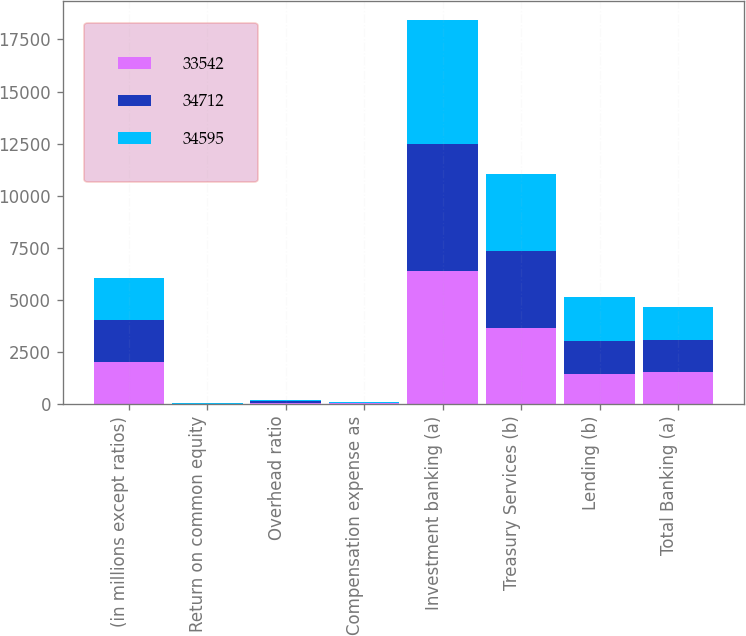Convert chart. <chart><loc_0><loc_0><loc_500><loc_500><stacked_bar_chart><ecel><fcel>(in millions except ratios)<fcel>Return on common equity<fcel>Overhead ratio<fcel>Compensation expense as<fcel>Investment banking (a)<fcel>Treasury Services (b)<fcel>Lending (b)<fcel>Total Banking (a)<nl><fcel>33542<fcel>2015<fcel>12<fcel>64<fcel>30<fcel>6376<fcel>3631<fcel>1461<fcel>1547<nl><fcel>34712<fcel>2014<fcel>10<fcel>67<fcel>30<fcel>6122<fcel>3728<fcel>1547<fcel>1547<nl><fcel>34595<fcel>2013<fcel>15<fcel>63<fcel>31<fcel>5922<fcel>3693<fcel>2147<fcel>1547<nl></chart> 